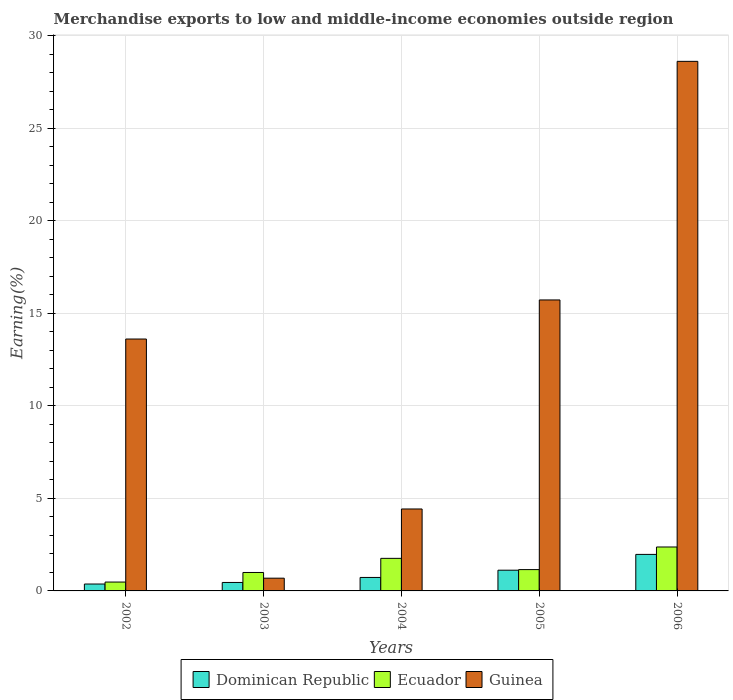Are the number of bars per tick equal to the number of legend labels?
Offer a very short reply. Yes. How many bars are there on the 3rd tick from the left?
Make the answer very short. 3. How many bars are there on the 1st tick from the right?
Offer a very short reply. 3. What is the percentage of amount earned from merchandise exports in Ecuador in 2003?
Make the answer very short. 1. Across all years, what is the maximum percentage of amount earned from merchandise exports in Ecuador?
Ensure brevity in your answer.  2.37. Across all years, what is the minimum percentage of amount earned from merchandise exports in Dominican Republic?
Provide a short and direct response. 0.37. In which year was the percentage of amount earned from merchandise exports in Guinea minimum?
Offer a terse response. 2003. What is the total percentage of amount earned from merchandise exports in Guinea in the graph?
Ensure brevity in your answer.  63.09. What is the difference between the percentage of amount earned from merchandise exports in Dominican Republic in 2003 and that in 2005?
Your response must be concise. -0.66. What is the difference between the percentage of amount earned from merchandise exports in Ecuador in 2005 and the percentage of amount earned from merchandise exports in Guinea in 2006?
Ensure brevity in your answer.  -27.47. What is the average percentage of amount earned from merchandise exports in Dominican Republic per year?
Ensure brevity in your answer.  0.93. In the year 2002, what is the difference between the percentage of amount earned from merchandise exports in Ecuador and percentage of amount earned from merchandise exports in Guinea?
Your answer should be very brief. -13.14. What is the ratio of the percentage of amount earned from merchandise exports in Ecuador in 2004 to that in 2006?
Your answer should be compact. 0.74. What is the difference between the highest and the second highest percentage of amount earned from merchandise exports in Guinea?
Your answer should be compact. 12.9. What is the difference between the highest and the lowest percentage of amount earned from merchandise exports in Ecuador?
Your response must be concise. 1.9. Is the sum of the percentage of amount earned from merchandise exports in Dominican Republic in 2003 and 2006 greater than the maximum percentage of amount earned from merchandise exports in Guinea across all years?
Offer a very short reply. No. What does the 2nd bar from the left in 2002 represents?
Give a very brief answer. Ecuador. What does the 2nd bar from the right in 2003 represents?
Keep it short and to the point. Ecuador. Is it the case that in every year, the sum of the percentage of amount earned from merchandise exports in Ecuador and percentage of amount earned from merchandise exports in Guinea is greater than the percentage of amount earned from merchandise exports in Dominican Republic?
Make the answer very short. Yes. How many years are there in the graph?
Provide a succinct answer. 5. Are the values on the major ticks of Y-axis written in scientific E-notation?
Give a very brief answer. No. Does the graph contain any zero values?
Provide a short and direct response. No. Does the graph contain grids?
Your answer should be compact. Yes. How many legend labels are there?
Your response must be concise. 3. How are the legend labels stacked?
Make the answer very short. Horizontal. What is the title of the graph?
Provide a short and direct response. Merchandise exports to low and middle-income economies outside region. Does "Mexico" appear as one of the legend labels in the graph?
Keep it short and to the point. No. What is the label or title of the Y-axis?
Your answer should be compact. Earning(%). What is the Earning(%) in Dominican Republic in 2002?
Your response must be concise. 0.37. What is the Earning(%) in Ecuador in 2002?
Make the answer very short. 0.48. What is the Earning(%) in Guinea in 2002?
Provide a short and direct response. 13.62. What is the Earning(%) in Dominican Republic in 2003?
Your answer should be very brief. 0.46. What is the Earning(%) in Ecuador in 2003?
Your answer should be very brief. 1. What is the Earning(%) of Guinea in 2003?
Give a very brief answer. 0.69. What is the Earning(%) of Dominican Republic in 2004?
Ensure brevity in your answer.  0.73. What is the Earning(%) of Ecuador in 2004?
Offer a very short reply. 1.76. What is the Earning(%) of Guinea in 2004?
Ensure brevity in your answer.  4.43. What is the Earning(%) in Dominican Republic in 2005?
Provide a short and direct response. 1.12. What is the Earning(%) of Ecuador in 2005?
Your response must be concise. 1.15. What is the Earning(%) of Guinea in 2005?
Make the answer very short. 15.73. What is the Earning(%) in Dominican Republic in 2006?
Provide a succinct answer. 1.97. What is the Earning(%) of Ecuador in 2006?
Give a very brief answer. 2.37. What is the Earning(%) of Guinea in 2006?
Your answer should be compact. 28.63. Across all years, what is the maximum Earning(%) in Dominican Republic?
Provide a short and direct response. 1.97. Across all years, what is the maximum Earning(%) in Ecuador?
Offer a very short reply. 2.37. Across all years, what is the maximum Earning(%) of Guinea?
Ensure brevity in your answer.  28.63. Across all years, what is the minimum Earning(%) in Dominican Republic?
Give a very brief answer. 0.37. Across all years, what is the minimum Earning(%) of Ecuador?
Your answer should be very brief. 0.48. Across all years, what is the minimum Earning(%) in Guinea?
Keep it short and to the point. 0.69. What is the total Earning(%) of Dominican Republic in the graph?
Your answer should be compact. 4.65. What is the total Earning(%) of Ecuador in the graph?
Your response must be concise. 6.76. What is the total Earning(%) in Guinea in the graph?
Offer a terse response. 63.09. What is the difference between the Earning(%) in Dominican Republic in 2002 and that in 2003?
Provide a short and direct response. -0.08. What is the difference between the Earning(%) of Ecuador in 2002 and that in 2003?
Keep it short and to the point. -0.52. What is the difference between the Earning(%) of Guinea in 2002 and that in 2003?
Offer a very short reply. 12.93. What is the difference between the Earning(%) in Dominican Republic in 2002 and that in 2004?
Provide a short and direct response. -0.35. What is the difference between the Earning(%) in Ecuador in 2002 and that in 2004?
Give a very brief answer. -1.28. What is the difference between the Earning(%) of Guinea in 2002 and that in 2004?
Offer a very short reply. 9.19. What is the difference between the Earning(%) of Dominican Republic in 2002 and that in 2005?
Make the answer very short. -0.75. What is the difference between the Earning(%) in Ecuador in 2002 and that in 2005?
Provide a succinct answer. -0.67. What is the difference between the Earning(%) of Guinea in 2002 and that in 2005?
Give a very brief answer. -2.11. What is the difference between the Earning(%) of Dominican Republic in 2002 and that in 2006?
Provide a short and direct response. -1.6. What is the difference between the Earning(%) of Ecuador in 2002 and that in 2006?
Your answer should be very brief. -1.9. What is the difference between the Earning(%) of Guinea in 2002 and that in 2006?
Make the answer very short. -15.01. What is the difference between the Earning(%) in Dominican Republic in 2003 and that in 2004?
Keep it short and to the point. -0.27. What is the difference between the Earning(%) in Ecuador in 2003 and that in 2004?
Provide a short and direct response. -0.76. What is the difference between the Earning(%) of Guinea in 2003 and that in 2004?
Ensure brevity in your answer.  -3.74. What is the difference between the Earning(%) in Dominican Republic in 2003 and that in 2005?
Ensure brevity in your answer.  -0.66. What is the difference between the Earning(%) in Ecuador in 2003 and that in 2005?
Provide a short and direct response. -0.16. What is the difference between the Earning(%) in Guinea in 2003 and that in 2005?
Offer a terse response. -15.04. What is the difference between the Earning(%) of Dominican Republic in 2003 and that in 2006?
Ensure brevity in your answer.  -1.52. What is the difference between the Earning(%) in Ecuador in 2003 and that in 2006?
Your answer should be very brief. -1.38. What is the difference between the Earning(%) in Guinea in 2003 and that in 2006?
Your answer should be very brief. -27.94. What is the difference between the Earning(%) in Dominican Republic in 2004 and that in 2005?
Your answer should be compact. -0.39. What is the difference between the Earning(%) of Ecuador in 2004 and that in 2005?
Offer a very short reply. 0.61. What is the difference between the Earning(%) of Guinea in 2004 and that in 2005?
Offer a terse response. -11.3. What is the difference between the Earning(%) of Dominican Republic in 2004 and that in 2006?
Your answer should be very brief. -1.25. What is the difference between the Earning(%) in Ecuador in 2004 and that in 2006?
Your answer should be very brief. -0.61. What is the difference between the Earning(%) in Guinea in 2004 and that in 2006?
Provide a succinct answer. -24.2. What is the difference between the Earning(%) of Dominican Republic in 2005 and that in 2006?
Your response must be concise. -0.85. What is the difference between the Earning(%) of Ecuador in 2005 and that in 2006?
Your response must be concise. -1.22. What is the difference between the Earning(%) in Guinea in 2005 and that in 2006?
Ensure brevity in your answer.  -12.9. What is the difference between the Earning(%) of Dominican Republic in 2002 and the Earning(%) of Ecuador in 2003?
Provide a succinct answer. -0.62. What is the difference between the Earning(%) of Dominican Republic in 2002 and the Earning(%) of Guinea in 2003?
Give a very brief answer. -0.32. What is the difference between the Earning(%) in Ecuador in 2002 and the Earning(%) in Guinea in 2003?
Offer a very short reply. -0.21. What is the difference between the Earning(%) of Dominican Republic in 2002 and the Earning(%) of Ecuador in 2004?
Give a very brief answer. -1.39. What is the difference between the Earning(%) in Dominican Republic in 2002 and the Earning(%) in Guinea in 2004?
Your answer should be very brief. -4.06. What is the difference between the Earning(%) of Ecuador in 2002 and the Earning(%) of Guinea in 2004?
Your answer should be very brief. -3.95. What is the difference between the Earning(%) in Dominican Republic in 2002 and the Earning(%) in Ecuador in 2005?
Your answer should be very brief. -0.78. What is the difference between the Earning(%) in Dominican Republic in 2002 and the Earning(%) in Guinea in 2005?
Ensure brevity in your answer.  -15.36. What is the difference between the Earning(%) of Ecuador in 2002 and the Earning(%) of Guinea in 2005?
Provide a short and direct response. -15.25. What is the difference between the Earning(%) in Dominican Republic in 2002 and the Earning(%) in Ecuador in 2006?
Offer a very short reply. -2. What is the difference between the Earning(%) in Dominican Republic in 2002 and the Earning(%) in Guinea in 2006?
Your answer should be compact. -28.25. What is the difference between the Earning(%) of Ecuador in 2002 and the Earning(%) of Guinea in 2006?
Provide a short and direct response. -28.15. What is the difference between the Earning(%) in Dominican Republic in 2003 and the Earning(%) in Ecuador in 2004?
Your answer should be very brief. -1.3. What is the difference between the Earning(%) in Dominican Republic in 2003 and the Earning(%) in Guinea in 2004?
Give a very brief answer. -3.97. What is the difference between the Earning(%) of Ecuador in 2003 and the Earning(%) of Guinea in 2004?
Offer a terse response. -3.43. What is the difference between the Earning(%) of Dominican Republic in 2003 and the Earning(%) of Ecuador in 2005?
Your response must be concise. -0.69. What is the difference between the Earning(%) in Dominican Republic in 2003 and the Earning(%) in Guinea in 2005?
Keep it short and to the point. -15.27. What is the difference between the Earning(%) in Ecuador in 2003 and the Earning(%) in Guinea in 2005?
Keep it short and to the point. -14.73. What is the difference between the Earning(%) in Dominican Republic in 2003 and the Earning(%) in Ecuador in 2006?
Keep it short and to the point. -1.92. What is the difference between the Earning(%) in Dominican Republic in 2003 and the Earning(%) in Guinea in 2006?
Offer a very short reply. -28.17. What is the difference between the Earning(%) of Ecuador in 2003 and the Earning(%) of Guinea in 2006?
Your answer should be compact. -27.63. What is the difference between the Earning(%) of Dominican Republic in 2004 and the Earning(%) of Ecuador in 2005?
Provide a short and direct response. -0.42. What is the difference between the Earning(%) of Dominican Republic in 2004 and the Earning(%) of Guinea in 2005?
Your answer should be compact. -15. What is the difference between the Earning(%) of Ecuador in 2004 and the Earning(%) of Guinea in 2005?
Your answer should be very brief. -13.97. What is the difference between the Earning(%) in Dominican Republic in 2004 and the Earning(%) in Ecuador in 2006?
Your answer should be compact. -1.65. What is the difference between the Earning(%) in Dominican Republic in 2004 and the Earning(%) in Guinea in 2006?
Offer a terse response. -27.9. What is the difference between the Earning(%) of Ecuador in 2004 and the Earning(%) of Guinea in 2006?
Give a very brief answer. -26.87. What is the difference between the Earning(%) in Dominican Republic in 2005 and the Earning(%) in Ecuador in 2006?
Keep it short and to the point. -1.25. What is the difference between the Earning(%) of Dominican Republic in 2005 and the Earning(%) of Guinea in 2006?
Provide a short and direct response. -27.51. What is the difference between the Earning(%) of Ecuador in 2005 and the Earning(%) of Guinea in 2006?
Provide a short and direct response. -27.47. What is the average Earning(%) in Dominican Republic per year?
Keep it short and to the point. 0.93. What is the average Earning(%) in Ecuador per year?
Your answer should be very brief. 1.35. What is the average Earning(%) of Guinea per year?
Provide a succinct answer. 12.62. In the year 2002, what is the difference between the Earning(%) of Dominican Republic and Earning(%) of Ecuador?
Provide a short and direct response. -0.11. In the year 2002, what is the difference between the Earning(%) of Dominican Republic and Earning(%) of Guinea?
Offer a terse response. -13.24. In the year 2002, what is the difference between the Earning(%) in Ecuador and Earning(%) in Guinea?
Keep it short and to the point. -13.14. In the year 2003, what is the difference between the Earning(%) of Dominican Republic and Earning(%) of Ecuador?
Give a very brief answer. -0.54. In the year 2003, what is the difference between the Earning(%) of Dominican Republic and Earning(%) of Guinea?
Provide a succinct answer. -0.23. In the year 2003, what is the difference between the Earning(%) of Ecuador and Earning(%) of Guinea?
Offer a terse response. 0.31. In the year 2004, what is the difference between the Earning(%) of Dominican Republic and Earning(%) of Ecuador?
Your response must be concise. -1.03. In the year 2004, what is the difference between the Earning(%) of Dominican Republic and Earning(%) of Guinea?
Your answer should be compact. -3.7. In the year 2004, what is the difference between the Earning(%) of Ecuador and Earning(%) of Guinea?
Keep it short and to the point. -2.67. In the year 2005, what is the difference between the Earning(%) of Dominican Republic and Earning(%) of Ecuador?
Offer a very short reply. -0.03. In the year 2005, what is the difference between the Earning(%) in Dominican Republic and Earning(%) in Guinea?
Provide a succinct answer. -14.61. In the year 2005, what is the difference between the Earning(%) of Ecuador and Earning(%) of Guinea?
Your answer should be very brief. -14.58. In the year 2006, what is the difference between the Earning(%) in Dominican Republic and Earning(%) in Ecuador?
Your answer should be compact. -0.4. In the year 2006, what is the difference between the Earning(%) of Dominican Republic and Earning(%) of Guinea?
Ensure brevity in your answer.  -26.65. In the year 2006, what is the difference between the Earning(%) in Ecuador and Earning(%) in Guinea?
Offer a very short reply. -26.25. What is the ratio of the Earning(%) in Dominican Republic in 2002 to that in 2003?
Give a very brief answer. 0.82. What is the ratio of the Earning(%) in Ecuador in 2002 to that in 2003?
Give a very brief answer. 0.48. What is the ratio of the Earning(%) in Guinea in 2002 to that in 2003?
Make the answer very short. 19.77. What is the ratio of the Earning(%) in Dominican Republic in 2002 to that in 2004?
Your response must be concise. 0.51. What is the ratio of the Earning(%) of Ecuador in 2002 to that in 2004?
Keep it short and to the point. 0.27. What is the ratio of the Earning(%) in Guinea in 2002 to that in 2004?
Offer a very short reply. 3.07. What is the ratio of the Earning(%) in Dominican Republic in 2002 to that in 2005?
Your answer should be compact. 0.33. What is the ratio of the Earning(%) in Ecuador in 2002 to that in 2005?
Your answer should be very brief. 0.42. What is the ratio of the Earning(%) in Guinea in 2002 to that in 2005?
Provide a short and direct response. 0.87. What is the ratio of the Earning(%) in Dominican Republic in 2002 to that in 2006?
Offer a terse response. 0.19. What is the ratio of the Earning(%) of Ecuador in 2002 to that in 2006?
Your answer should be compact. 0.2. What is the ratio of the Earning(%) in Guinea in 2002 to that in 2006?
Keep it short and to the point. 0.48. What is the ratio of the Earning(%) of Dominican Republic in 2003 to that in 2004?
Provide a short and direct response. 0.63. What is the ratio of the Earning(%) of Ecuador in 2003 to that in 2004?
Your answer should be compact. 0.57. What is the ratio of the Earning(%) in Guinea in 2003 to that in 2004?
Provide a succinct answer. 0.16. What is the ratio of the Earning(%) of Dominican Republic in 2003 to that in 2005?
Provide a succinct answer. 0.41. What is the ratio of the Earning(%) of Ecuador in 2003 to that in 2005?
Your answer should be compact. 0.87. What is the ratio of the Earning(%) in Guinea in 2003 to that in 2005?
Your answer should be very brief. 0.04. What is the ratio of the Earning(%) of Dominican Republic in 2003 to that in 2006?
Give a very brief answer. 0.23. What is the ratio of the Earning(%) in Ecuador in 2003 to that in 2006?
Provide a short and direct response. 0.42. What is the ratio of the Earning(%) of Guinea in 2003 to that in 2006?
Provide a short and direct response. 0.02. What is the ratio of the Earning(%) in Dominican Republic in 2004 to that in 2005?
Provide a short and direct response. 0.65. What is the ratio of the Earning(%) in Ecuador in 2004 to that in 2005?
Offer a terse response. 1.53. What is the ratio of the Earning(%) in Guinea in 2004 to that in 2005?
Provide a short and direct response. 0.28. What is the ratio of the Earning(%) in Dominican Republic in 2004 to that in 2006?
Your answer should be very brief. 0.37. What is the ratio of the Earning(%) of Ecuador in 2004 to that in 2006?
Offer a very short reply. 0.74. What is the ratio of the Earning(%) in Guinea in 2004 to that in 2006?
Provide a short and direct response. 0.15. What is the ratio of the Earning(%) in Dominican Republic in 2005 to that in 2006?
Give a very brief answer. 0.57. What is the ratio of the Earning(%) in Ecuador in 2005 to that in 2006?
Give a very brief answer. 0.49. What is the ratio of the Earning(%) of Guinea in 2005 to that in 2006?
Provide a succinct answer. 0.55. What is the difference between the highest and the second highest Earning(%) of Dominican Republic?
Provide a succinct answer. 0.85. What is the difference between the highest and the second highest Earning(%) of Ecuador?
Your response must be concise. 0.61. What is the difference between the highest and the second highest Earning(%) of Guinea?
Make the answer very short. 12.9. What is the difference between the highest and the lowest Earning(%) of Dominican Republic?
Offer a terse response. 1.6. What is the difference between the highest and the lowest Earning(%) in Ecuador?
Ensure brevity in your answer.  1.9. What is the difference between the highest and the lowest Earning(%) in Guinea?
Your response must be concise. 27.94. 